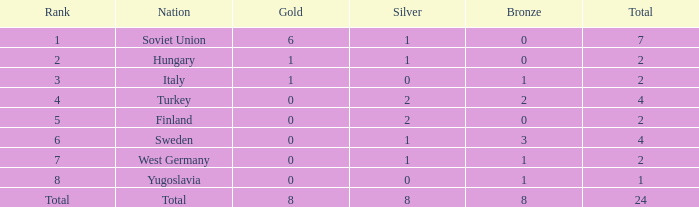What is the lowest Bronze, when Gold is less than 0? None. 